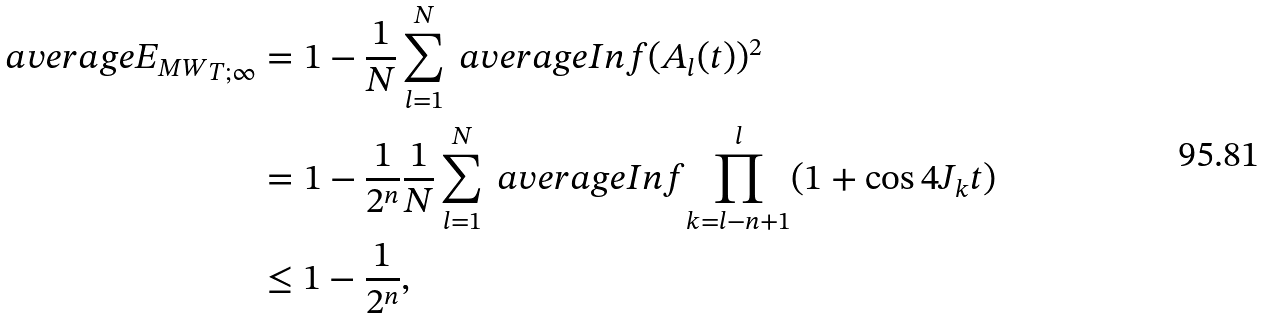Convert formula to latex. <formula><loc_0><loc_0><loc_500><loc_500>\ a v e r a g e { E _ { M W } } _ { T ; \infty } & = 1 - \frac { 1 } { N } \sum _ { l = 1 } ^ { N } \ a v e r a g e I n f { ( A _ { l } ( t ) ) ^ { 2 } } \\ & = 1 - \frac { 1 } { 2 ^ { n } } \frac { 1 } { N } \sum _ { l = 1 } ^ { N } \ a v e r a g e I n f { \prod _ { k = l - n + 1 } ^ { l } ( 1 + \cos 4 J _ { k } t ) } \\ & \leq 1 - \frac { 1 } { 2 ^ { n } } ,</formula> 